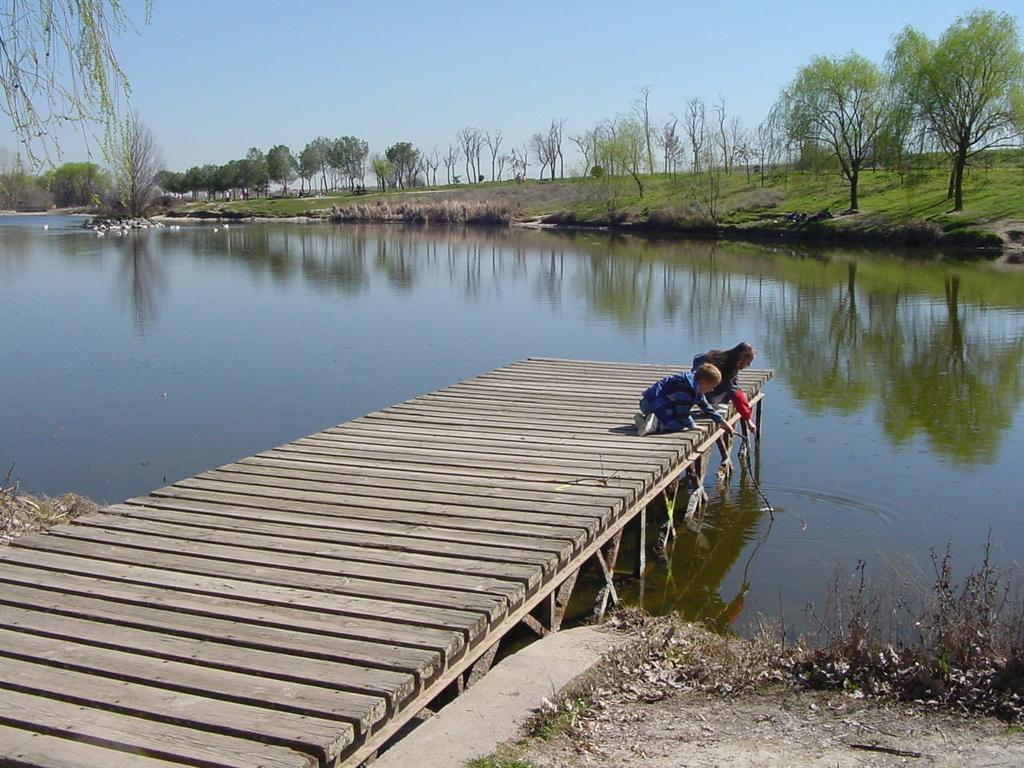How many children are in the image? There are two children in the image. Where are the children located? The children are on a wooden bridge. What is one child holding in the image? One child is holding something. What can be seen below the wooden bridge? There is water visible in the image. What is visible in the background of the image? There are trees in the background. What is the color of the sky in the image? The sky is blue and white in color. What type of spy equipment can be seen in the image? There is no spy equipment present in the image. What is the texture of the leg of the wooden bridge? The image does not provide enough detail to determine the texture of the wooden bridge's leg. 